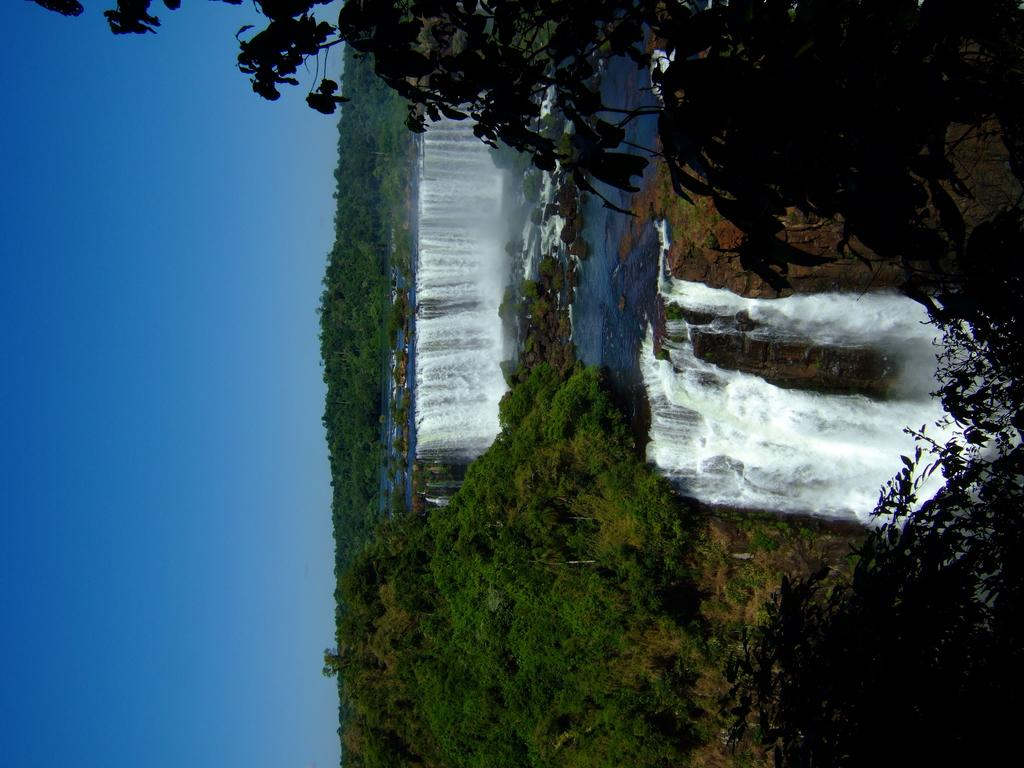What type of natural features can be seen in the image? There are trees, waterfalls, and rocks in the image. What part of the sky is visible in the image? The sky is visible on the left side of the image. Can you tell me how many carpenters are working on the waterfalls in the image? There are no carpenters present in the image; it features natural waterfalls. What type of expertise is required to create the rocks in the image? The rocks in the image are natural formations and do not require any human expertise to create. 